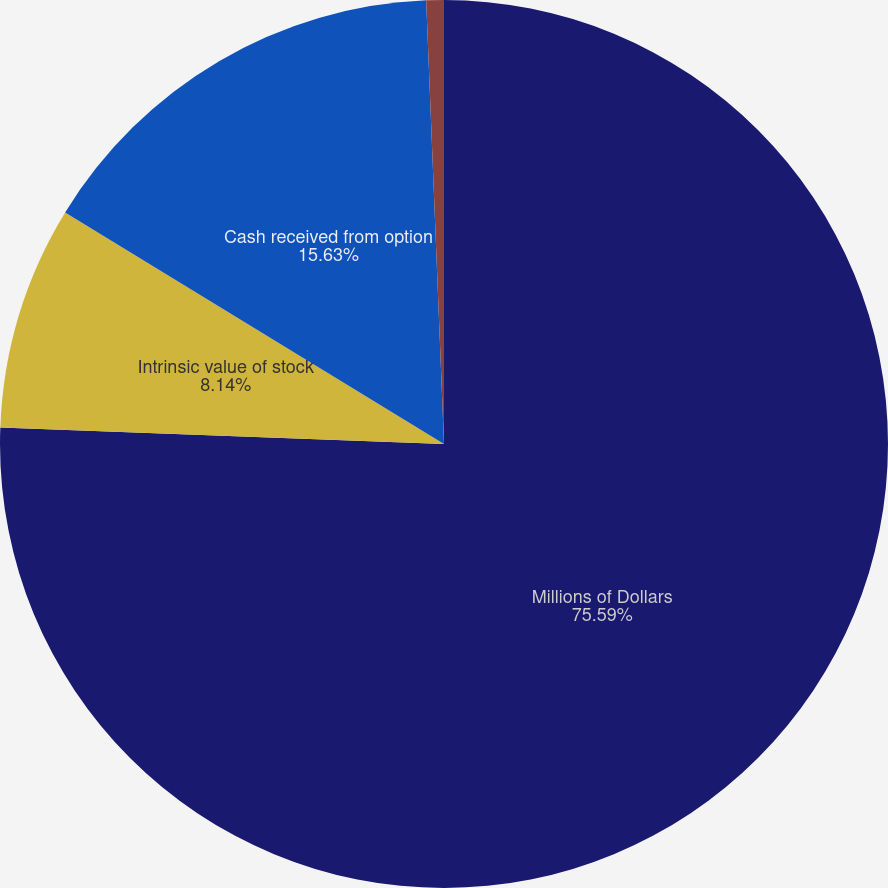Convert chart. <chart><loc_0><loc_0><loc_500><loc_500><pie_chart><fcel>Millions of Dollars<fcel>Intrinsic value of stock<fcel>Cash received from option<fcel>Tax benefit realized from<nl><fcel>75.59%<fcel>8.14%<fcel>15.63%<fcel>0.64%<nl></chart> 